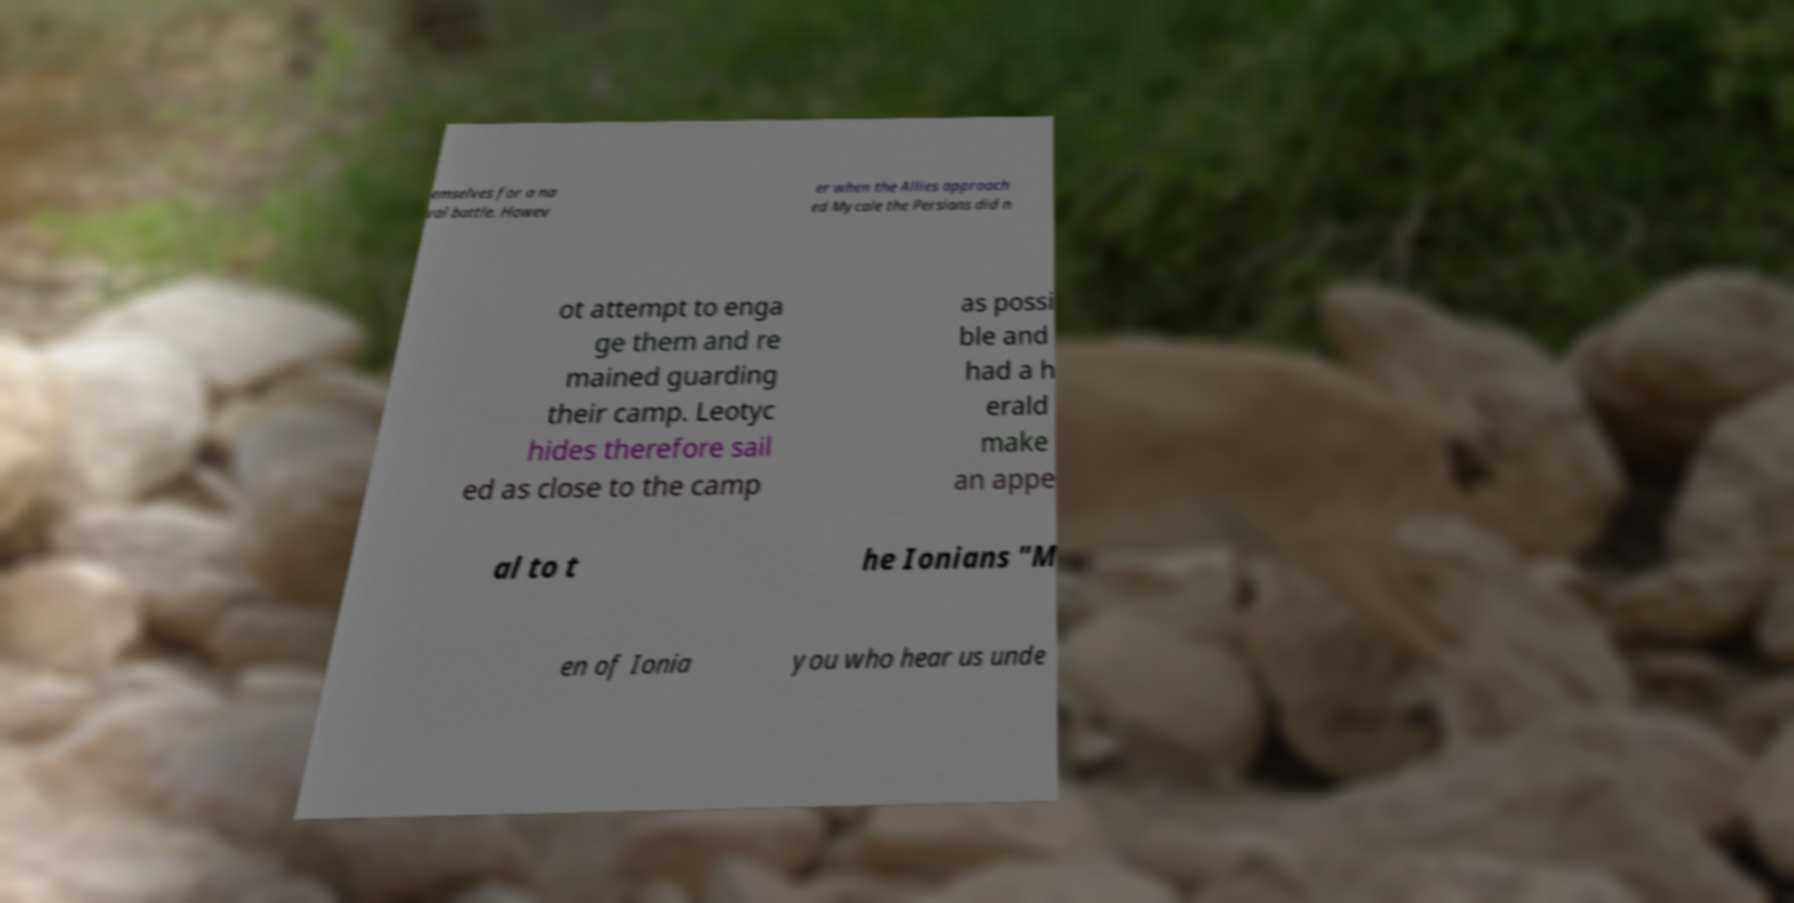There's text embedded in this image that I need extracted. Can you transcribe it verbatim? emselves for a na val battle. Howev er when the Allies approach ed Mycale the Persians did n ot attempt to enga ge them and re mained guarding their camp. Leotyc hides therefore sail ed as close to the camp as possi ble and had a h erald make an appe al to t he Ionians "M en of Ionia you who hear us unde 